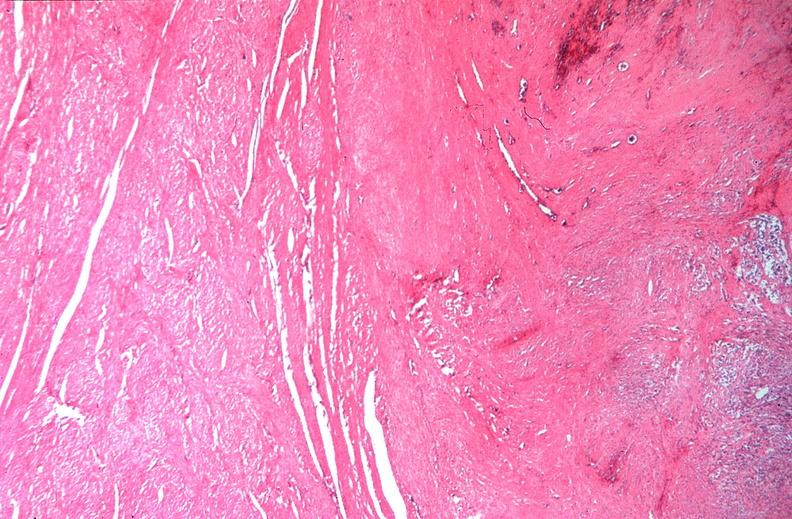what is present?
Answer the question using a single word or phrase. Female reproductive 